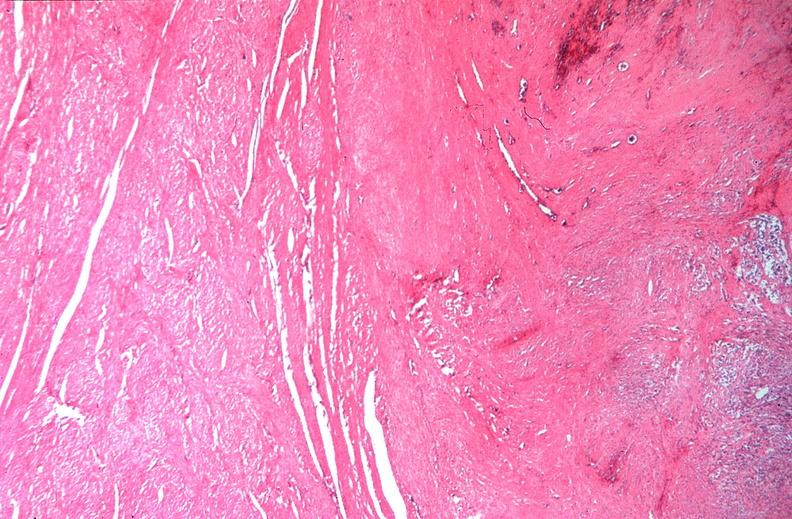what is present?
Answer the question using a single word or phrase. Female reproductive 